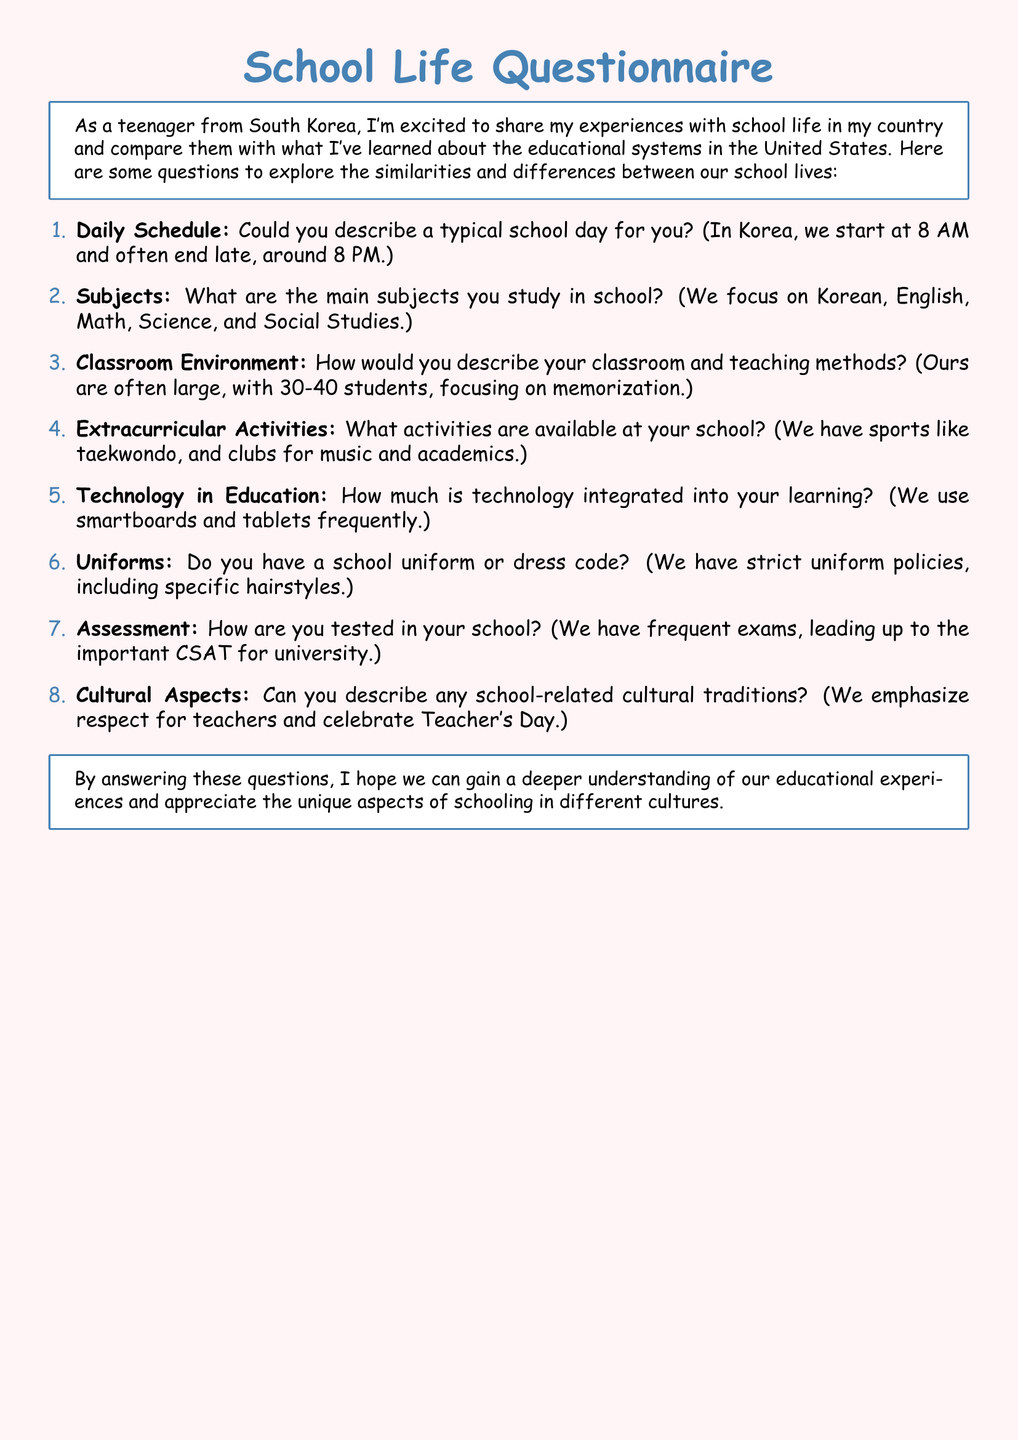What time does school start in Korea? According to the document, school in Korea starts at 8 AM.
Answer: 8 AM What is the focus of subjects studied in Korea? The document states that subjects in Korea focus on Korean, English, Math, Science, and Social Studies.
Answer: Korean, English, Math, Science, Social Studies How many students are typically in a Korean classroom? The document mentions that Korean classrooms often have 30-40 students.
Answer: 30-40 students What types of extracurricular activities are mentioned? The document lists sports like taekwondo and clubs for music and academics as extracurricular activities in Korea.
Answer: Taekwondo, music, academics What technology is frequently used in Korean education? According to the document, smartboards and tablets are frequently used in Korea.
Answer: Smartboards and tablets Is there a uniform policy in Korean schools? The document indicates that there are strict uniform policies in Korean schools.
Answer: Strict uniform policies What is a significant exam mentioned in the document? The document states that the important CSAT for university is a significant exam in Korea.
Answer: CSAT What is emphasized as a cultural tradition in Korean schools? The document notes that respect for teachers is emphasized as a cultural tradition.
Answer: Respect for teachers 